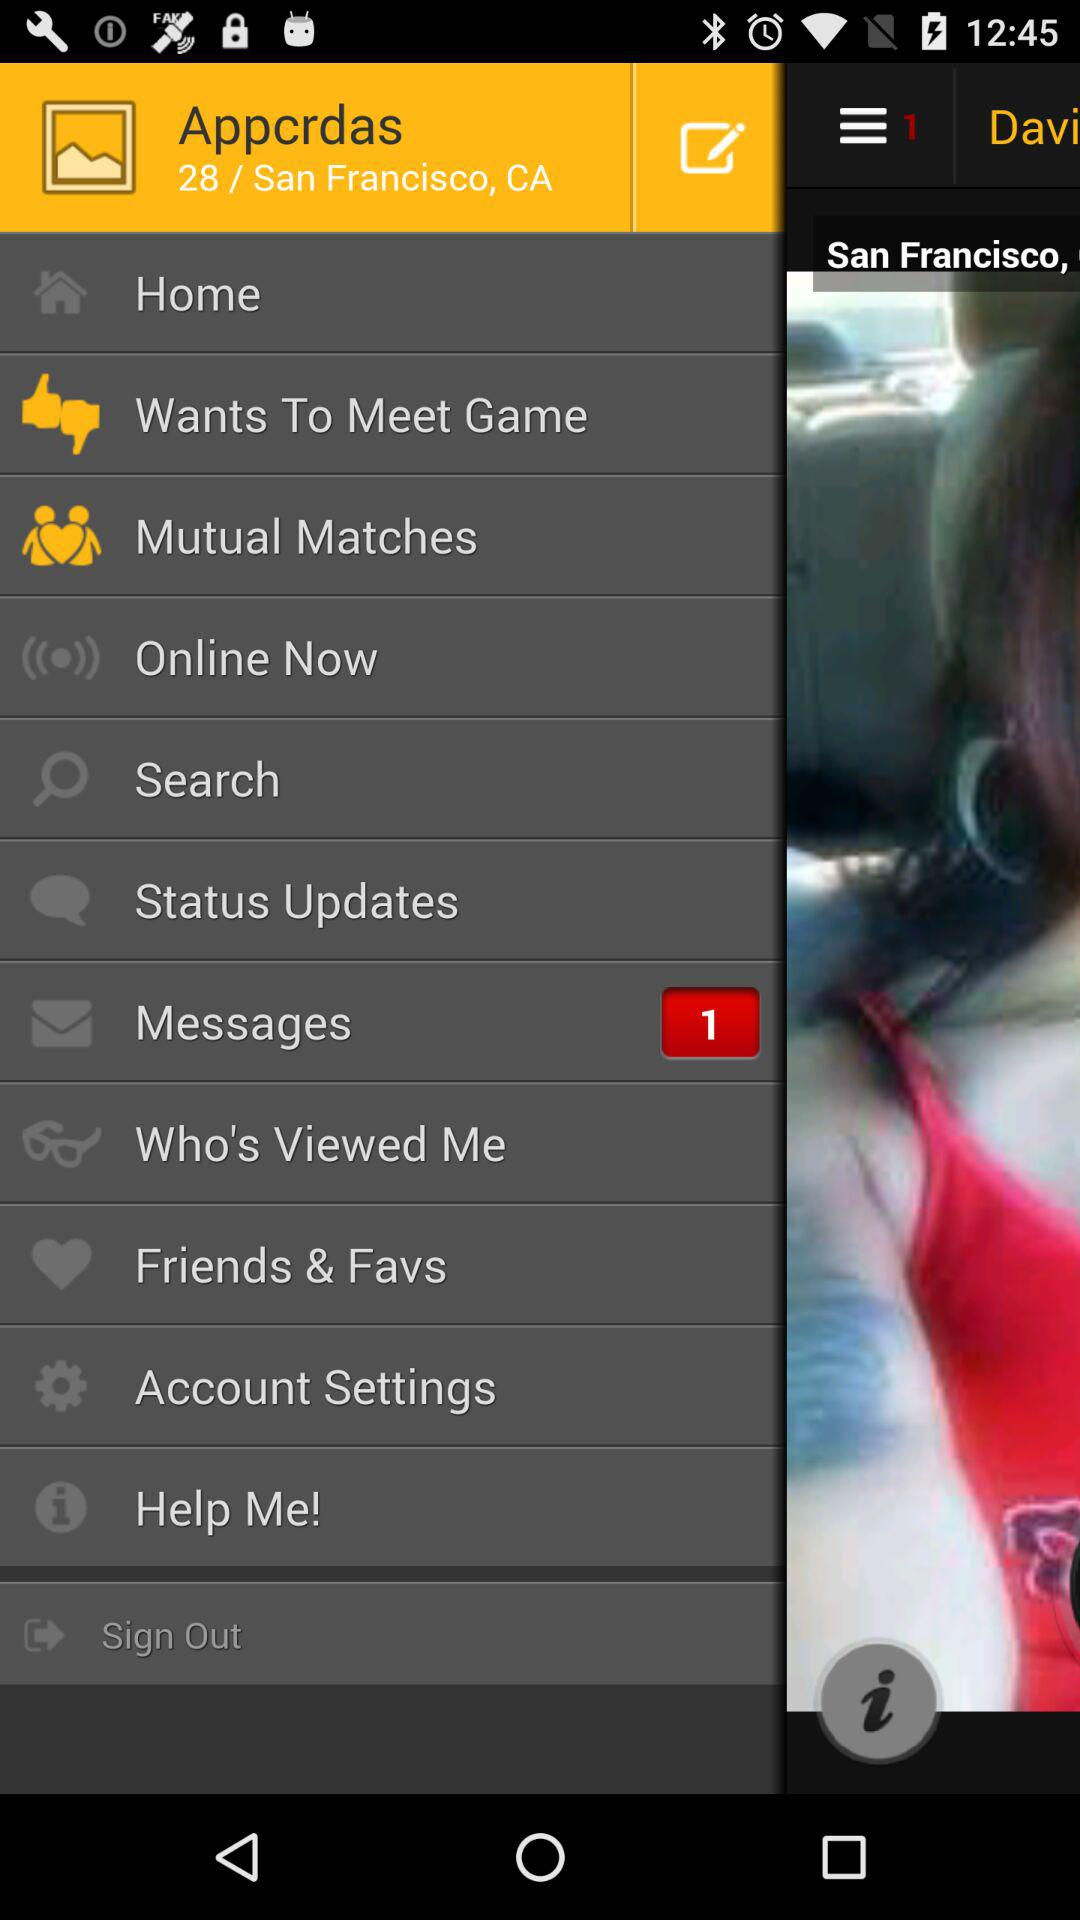What is the given age? The given age is 28. 